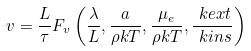Convert formula to latex. <formula><loc_0><loc_0><loc_500><loc_500>v = \frac { L } { \tau } F _ { v } \left ( \frac { \lambda } { L } , \frac { a } { \rho k T } , \frac { \mu _ { e } } { \rho k T } , \frac { \ k e x t } { \ k i n s } \right )</formula> 